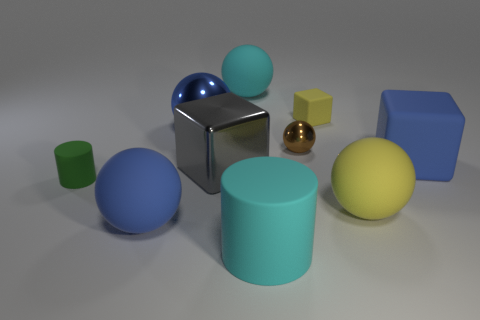Subtract all cyan spheres. How many spheres are left? 4 Subtract all yellow balls. How many balls are left? 4 Subtract all red balls. Subtract all cyan cylinders. How many balls are left? 5 Subtract all cubes. How many objects are left? 7 Subtract all yellow rubber spheres. Subtract all green cylinders. How many objects are left? 8 Add 4 large shiny spheres. How many large shiny spheres are left? 5 Add 2 large brown metal spheres. How many large brown metal spheres exist? 2 Subtract 0 red blocks. How many objects are left? 10 